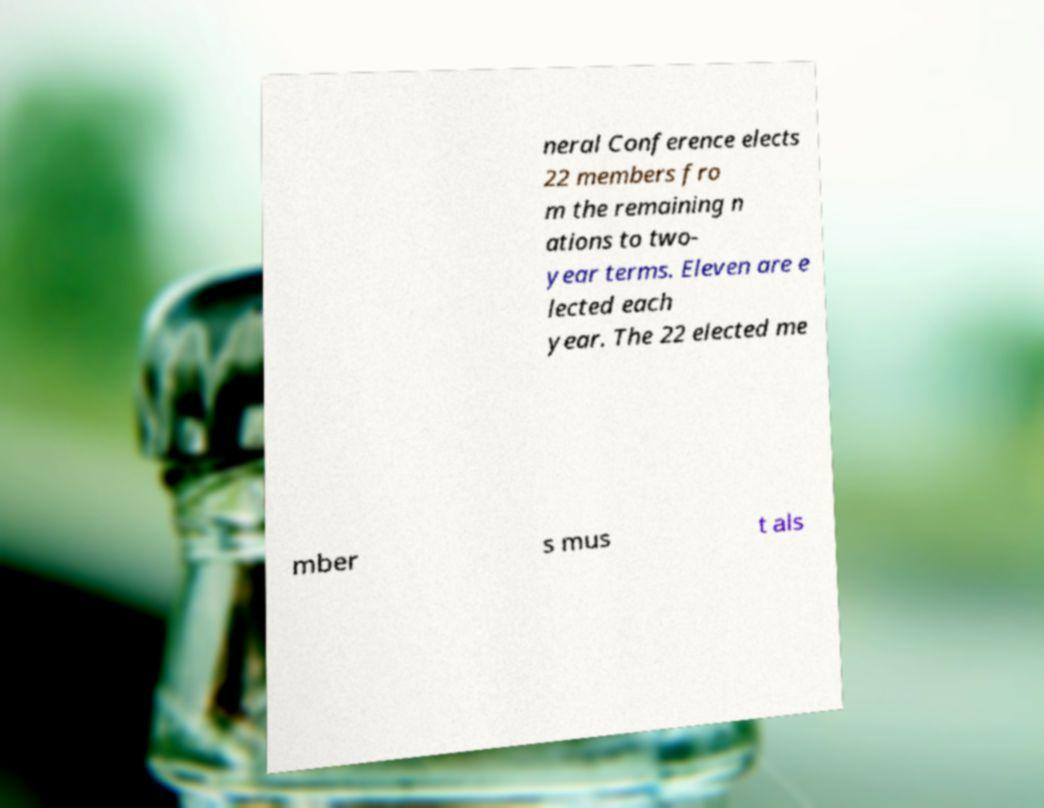Can you read and provide the text displayed in the image?This photo seems to have some interesting text. Can you extract and type it out for me? neral Conference elects 22 members fro m the remaining n ations to two- year terms. Eleven are e lected each year. The 22 elected me mber s mus t als 